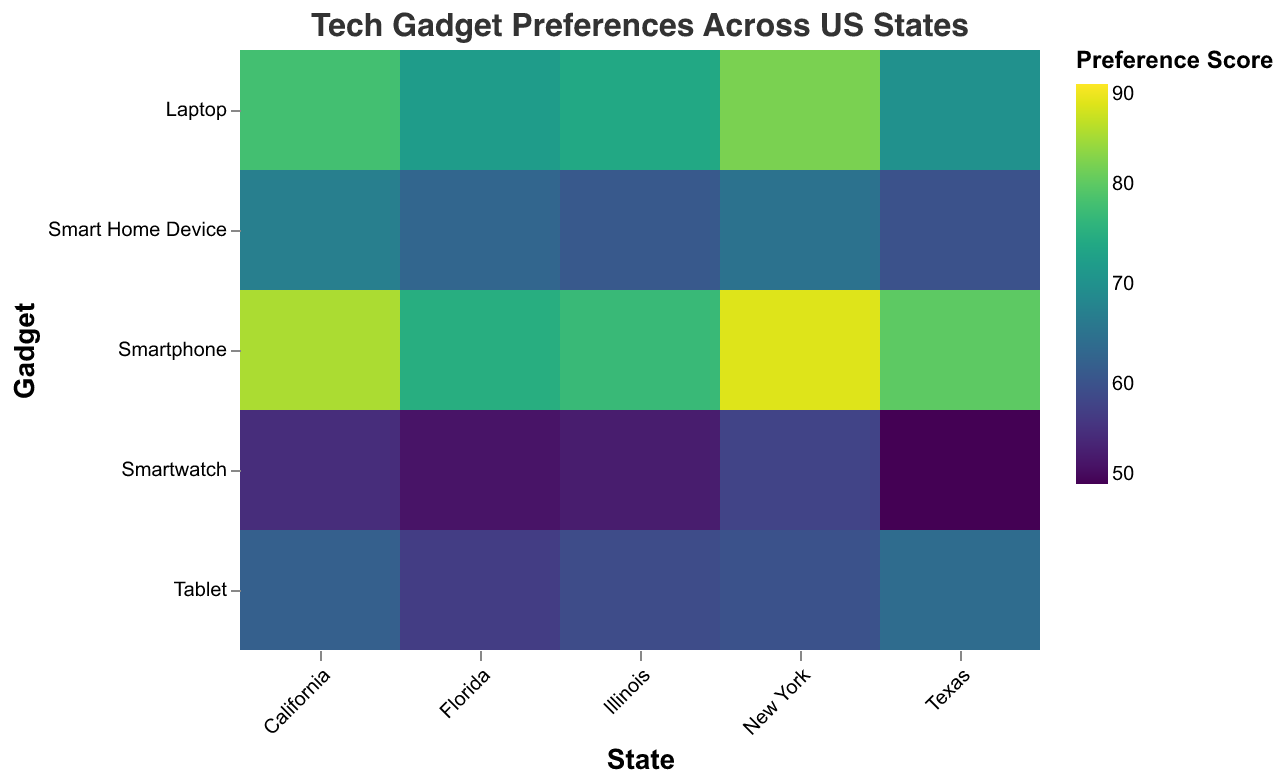What is the title of the heatmap? The title of the heatmap is displayed at the top and reads "Tech Gadget Preferences Across US States".
Answer: Tech Gadget Preferences Across US States Which state has the highest preference score for smartphones? The heatmap uses different shades of color to represent preference scores. The highest score for smartphones appears in New York, where the color is the darkest.
Answer: New York How many gadgets are tracked in this heatmap? The y-axis lists all the gadgets being tracked. By counting the items, you can see that there are five gadgets: Smartphone, Laptop, Tablet, Smartwatch, and Smart Home Device.
Answer: Five Which gadget has the highest preference score overall and in which state? By looking for the darkest cell in the heatmap, you can see that the highest score overall is for Smartphones in New York, with a score of 88.
Answer: Smartphone in New York What is the preference score range depicted in the color scale? The color scale on the right of the heatmap shows the range of preference scores represented, which extends from 50 to 90.
Answer: 50 to 90 Which state has the lowest preference score for smart home devices? Scan the cells corresponding to smart home devices. Texas has the lowest color intensity for smart home devices, indicating a lower score of 60.
Answer: Texas Compare the preference scores for laptops between California and Florida. Which state has a higher score? To compare the scores, check the color intensity for laptops in California and Florida. California has a score of 78, while Florida has a score of 72, so California has the higher score.
Answer: California What is the average preference score for tablets across all the states? Add up the preference scores for tablets in all the states (California: 62, Texas: 64, New York: 60, Florida: 57, Illinois: 59) and divide by the number of states (5). The calculation is (62 + 64 + 60 + 57 + 59) / 5 = 60.4.
Answer: 60.4 Which state has the most balanced preference scores across all gadgets (smallest range between the highest and lowest scores)? Check the range for each state by subtracting the lowest score from the highest score in each state. California: 85-55=30, Texas: 80-50=30, New York: 88-58=30, Florida: 75-52=23, Illinois: 77-53=24. Florida has the smallest range of 23.
Answer: Florida Identify the three states with the highest preference scores for smartwatches. Look at the smartwatches row and identify the three darkest cells. New York: 58, Illinois: 53, California: 55. These states have the highest preference scores for smartwatches.
Answer: New York, Illinois, California 